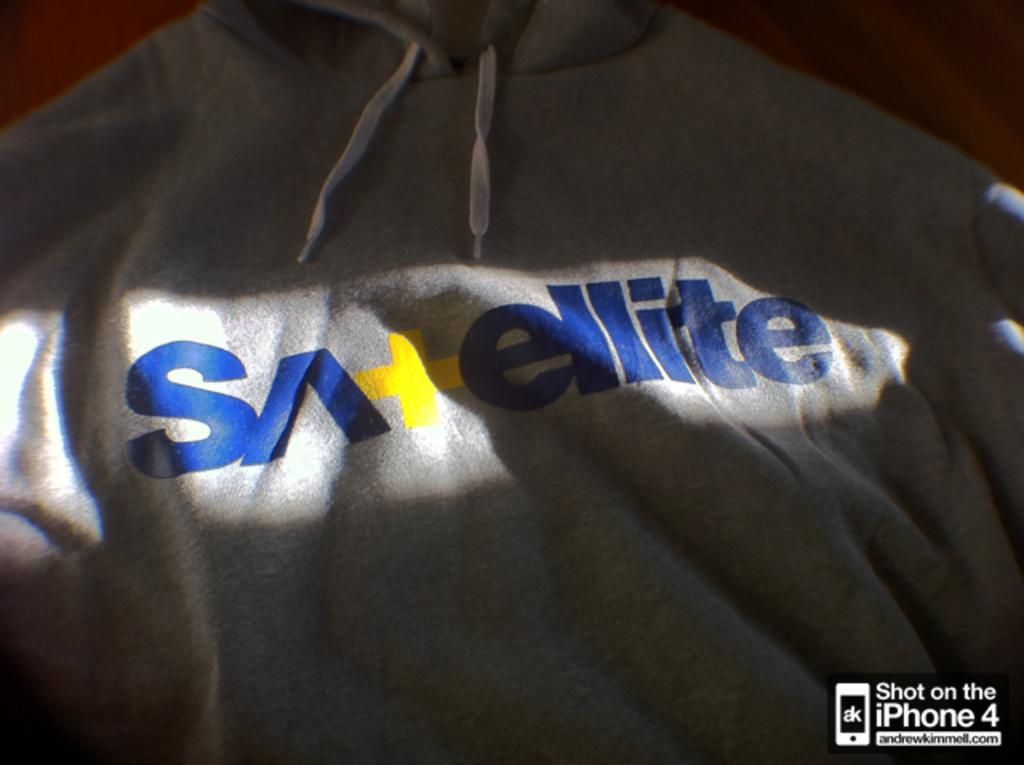<image>
Create a compact narrative representing the image presented. A grey hoodie has the word Satellite on it. 